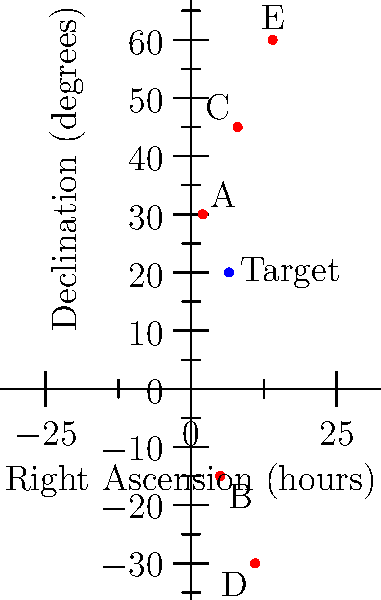A newly discovered celestial object has been observed with coordinates Right Ascension (RA) = 6h 30m and Declination (Dec) = +20°. Using the 2D star chart provided, which two known stars (labeled A through E) form a triangle with the target object such that the target is located inside the triangle? To solve this problem, we need to follow these steps:

1) First, locate the target object on the chart. The coordinates given are RA = 6h 30m and Dec = +20°. This corresponds to the point (6.5, 20) on our chart.

2) Now, we need to find three stars that form a triangle containing this point. Let's examine each star:

   A: (2, 30)
   B: (5, -15)
   C: (8, 45)
   D: (11, -30)
   E: (14, 60)

3) We can eliminate D and E immediately as they are too far to the right (higher RA) to form a triangle containing the target.

4) Looking at the remaining stars A, B, and C, we can see that they form a triangle that encompasses the target object.

5) To verify, we can check if the target point (6.5, 20) is inside the triangle formed by A, B, and C:
   - It's to the right of A
   - It's to the left of C
   - It's above B

6) Therefore, stars A, B, and C form the triangle that contains the target object.
Answer: A, B, and C 